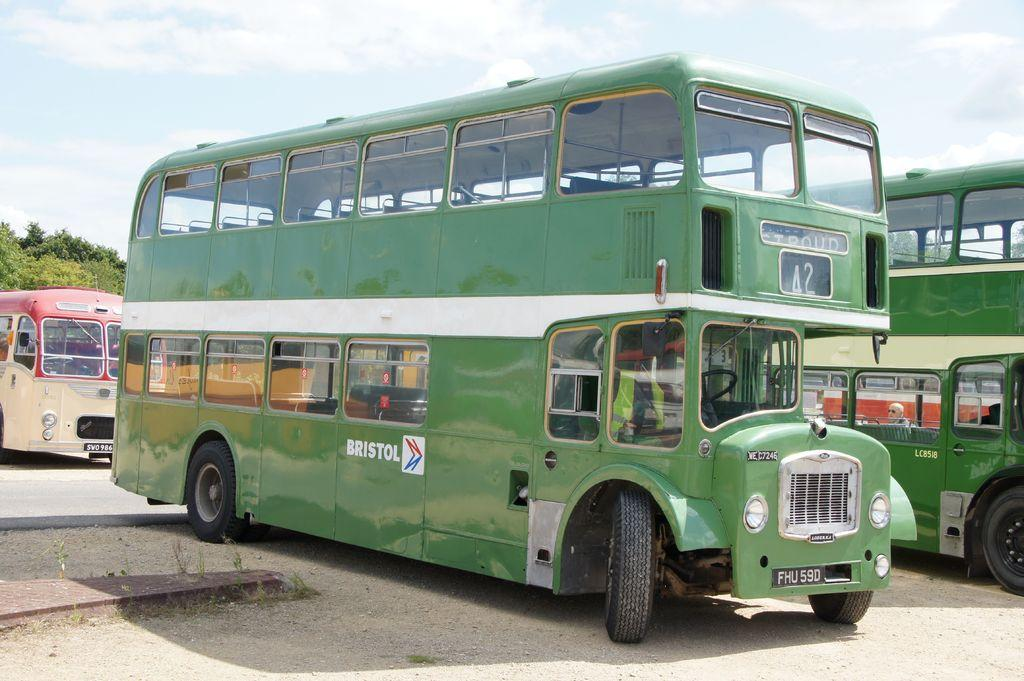<image>
Relay a brief, clear account of the picture shown. A double-decker green bus has Bristol in white lettering on its side. 